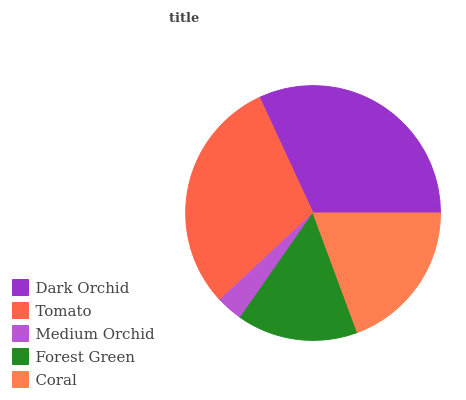Is Medium Orchid the minimum?
Answer yes or no. Yes. Is Dark Orchid the maximum?
Answer yes or no. Yes. Is Tomato the minimum?
Answer yes or no. No. Is Tomato the maximum?
Answer yes or no. No. Is Dark Orchid greater than Tomato?
Answer yes or no. Yes. Is Tomato less than Dark Orchid?
Answer yes or no. Yes. Is Tomato greater than Dark Orchid?
Answer yes or no. No. Is Dark Orchid less than Tomato?
Answer yes or no. No. Is Coral the high median?
Answer yes or no. Yes. Is Coral the low median?
Answer yes or no. Yes. Is Dark Orchid the high median?
Answer yes or no. No. Is Medium Orchid the low median?
Answer yes or no. No. 